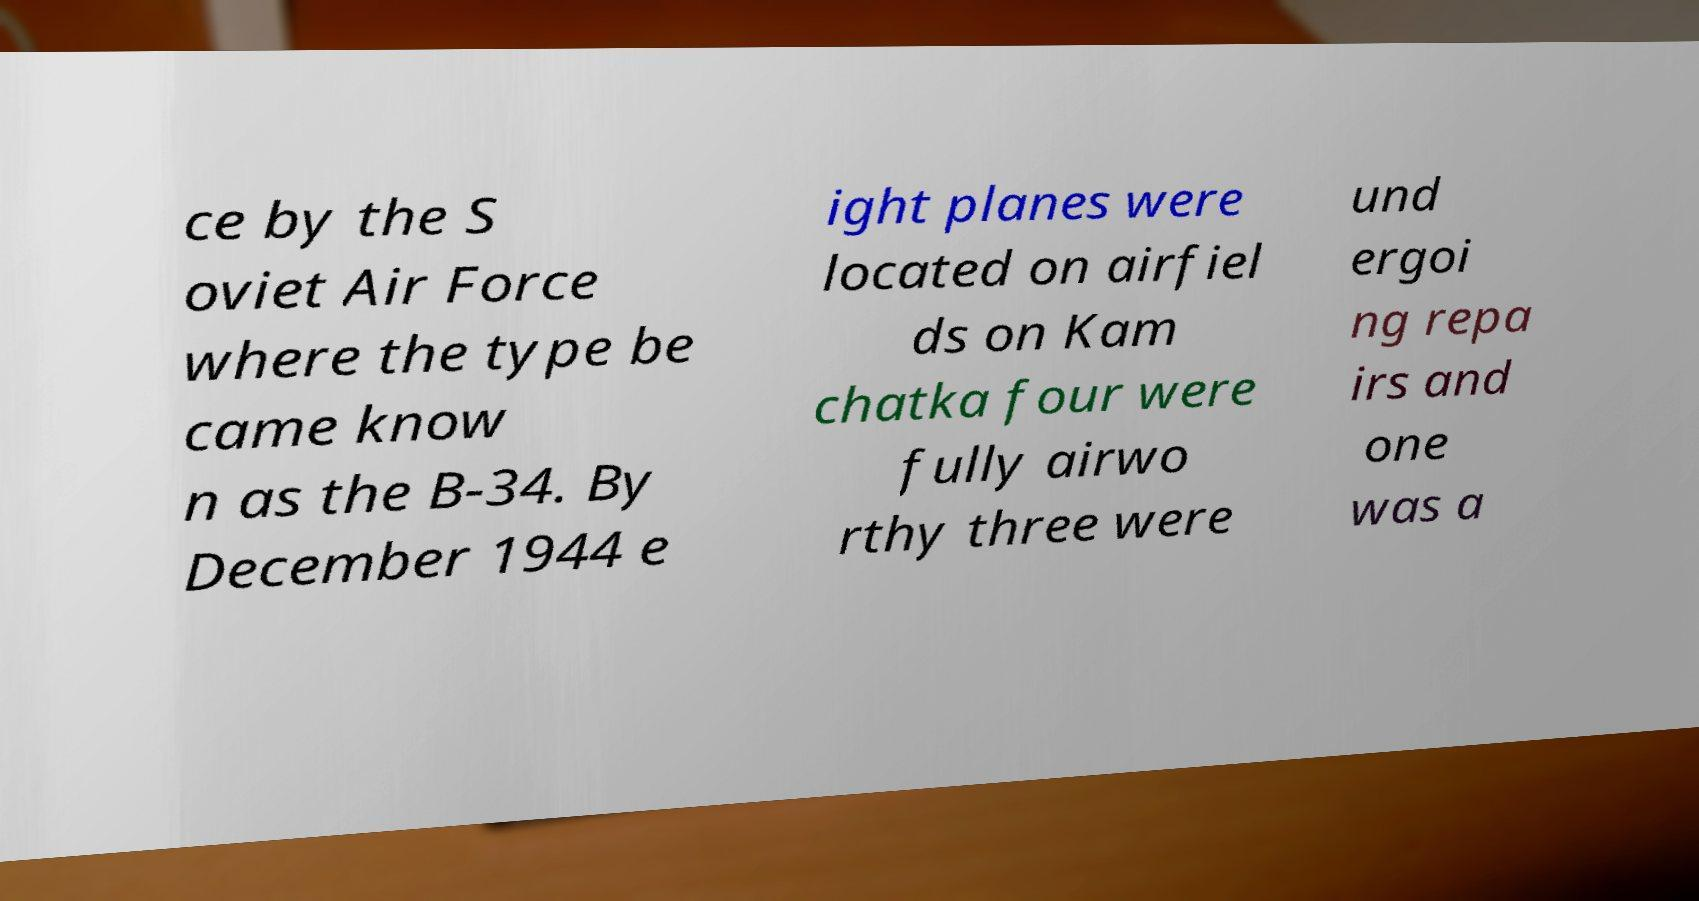Could you extract and type out the text from this image? ce by the S oviet Air Force where the type be came know n as the B-34. By December 1944 e ight planes were located on airfiel ds on Kam chatka four were fully airwo rthy three were und ergoi ng repa irs and one was a 